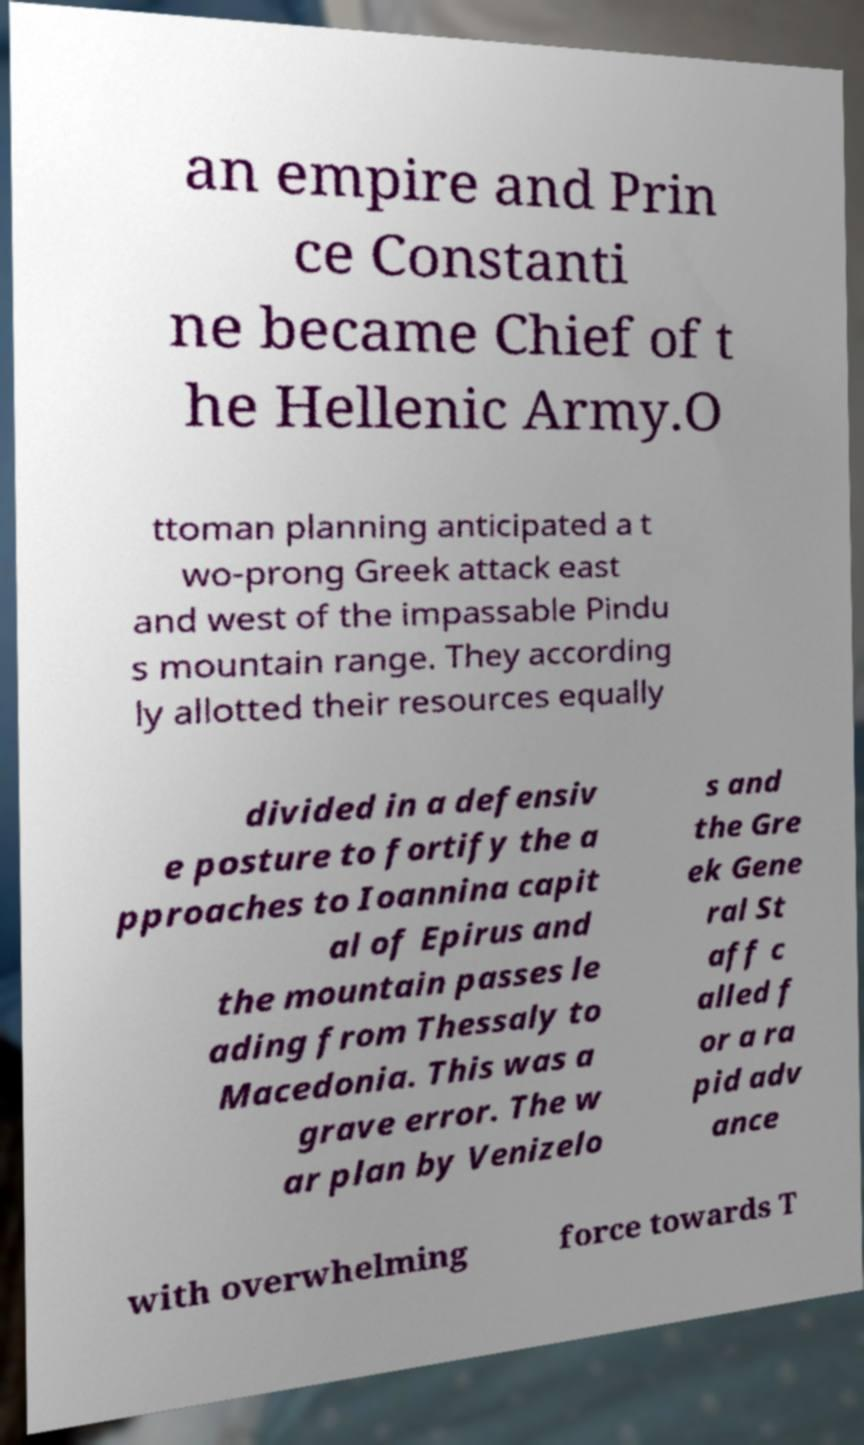For documentation purposes, I need the text within this image transcribed. Could you provide that? an empire and Prin ce Constanti ne became Chief of t he Hellenic Army.O ttoman planning anticipated a t wo-prong Greek attack east and west of the impassable Pindu s mountain range. They according ly allotted their resources equally divided in a defensiv e posture to fortify the a pproaches to Ioannina capit al of Epirus and the mountain passes le ading from Thessaly to Macedonia. This was a grave error. The w ar plan by Venizelo s and the Gre ek Gene ral St aff c alled f or a ra pid adv ance with overwhelming force towards T 